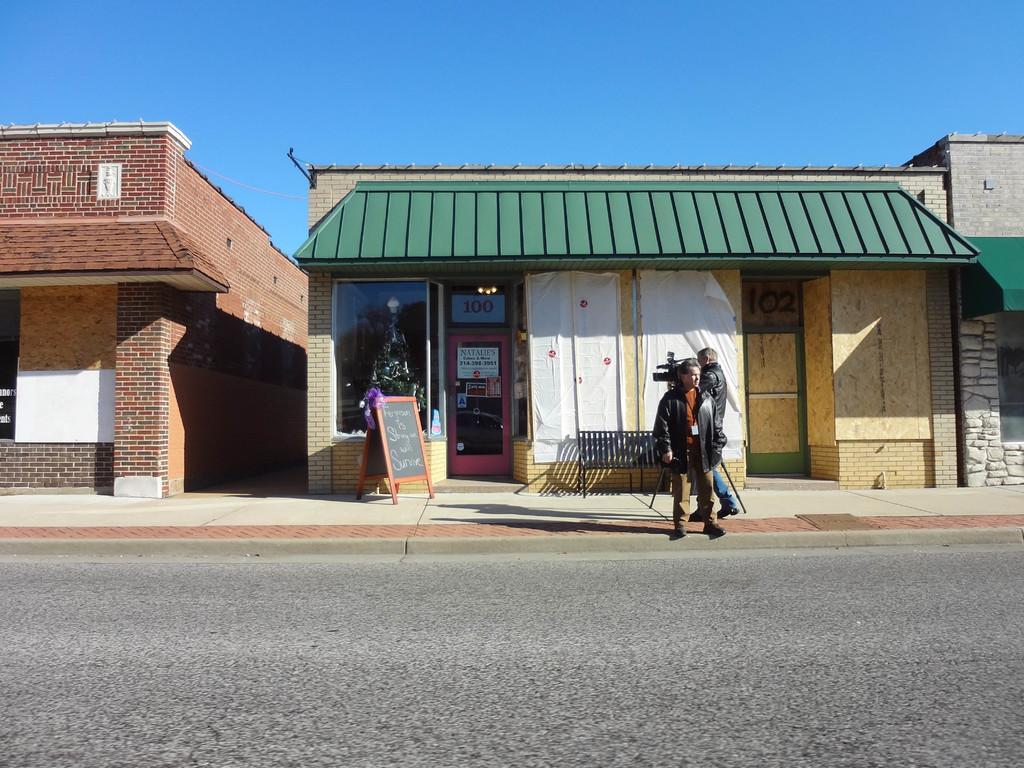Describe this image in one or two sentences. There is a road. 2 people are standing wearing jackets. There is a bench, a board and buildings at the back. 